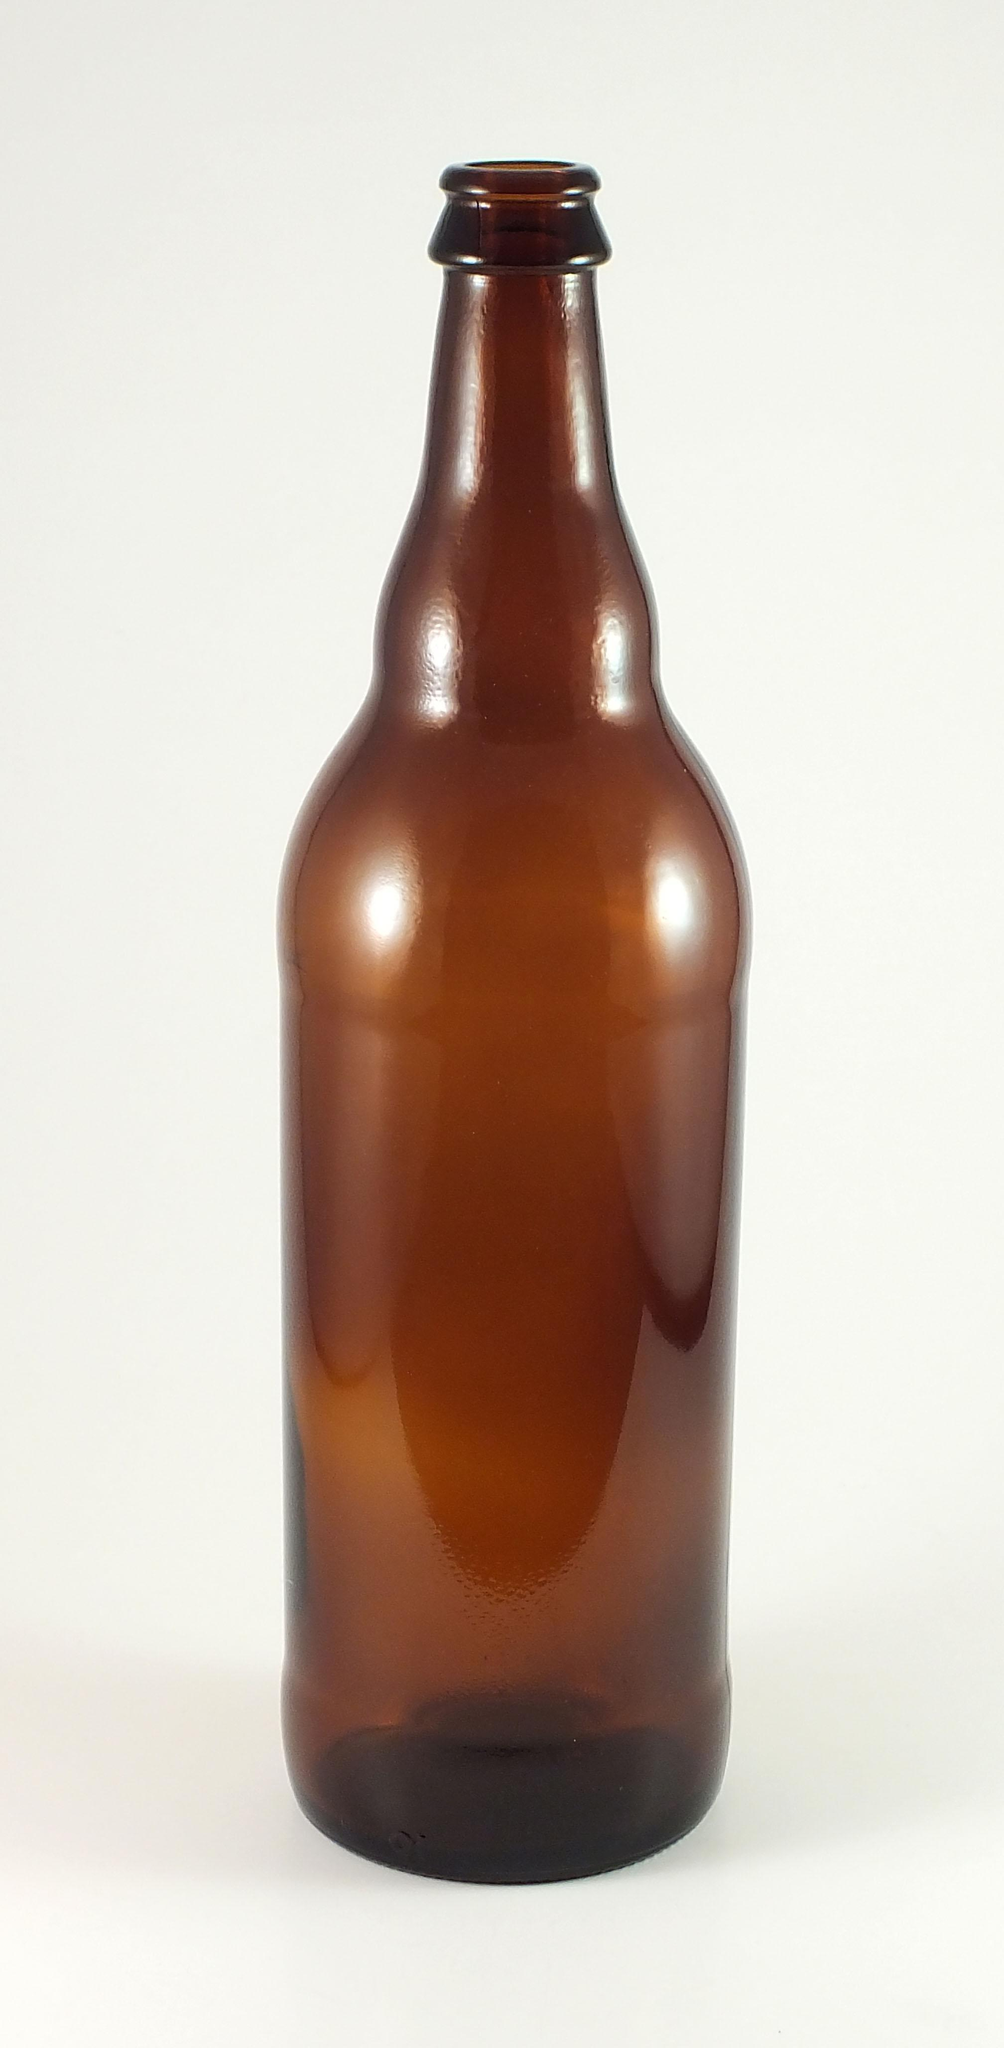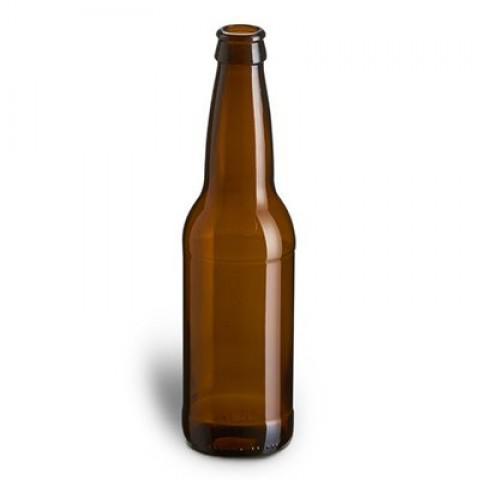The first image is the image on the left, the second image is the image on the right. Analyze the images presented: Is the assertion "More bottles are depicted in the right image than the left." valid? Answer yes or no. No. 